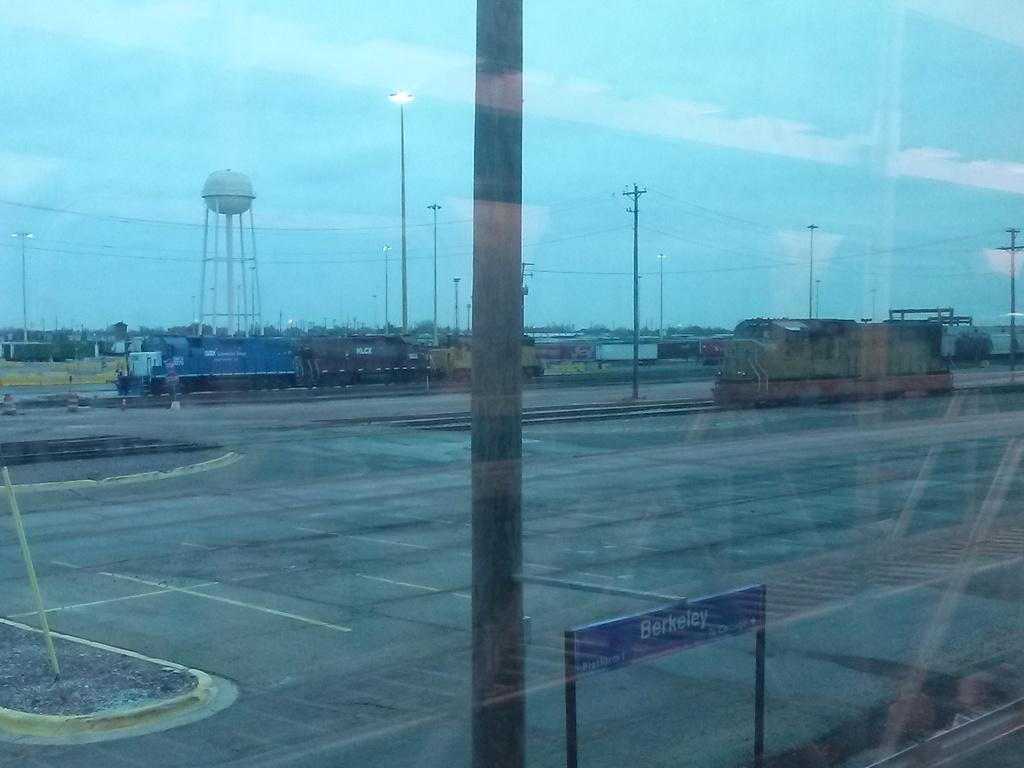<image>
Relay a brief, clear account of the picture shown. A large window shows a blue sign outdoors that say, "Berkeley". 